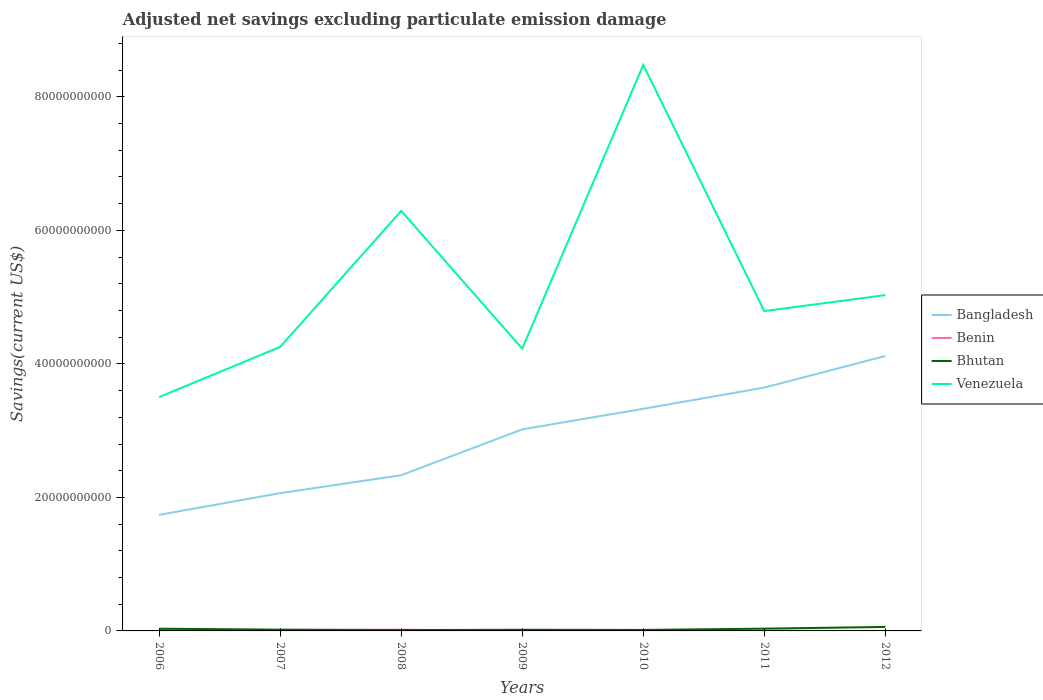How many different coloured lines are there?
Your response must be concise. 4. Is the number of lines equal to the number of legend labels?
Your response must be concise. No. Across all years, what is the maximum adjusted net savings in Venezuela?
Make the answer very short. 3.50e+1. What is the total adjusted net savings in Bhutan in the graph?
Keep it short and to the point. -4.21e+08. What is the difference between the highest and the second highest adjusted net savings in Venezuela?
Your answer should be very brief. 4.98e+1. What is the difference between the highest and the lowest adjusted net savings in Benin?
Your answer should be very brief. 3. Is the adjusted net savings in Bangladesh strictly greater than the adjusted net savings in Venezuela over the years?
Give a very brief answer. Yes. How many lines are there?
Your response must be concise. 4. How are the legend labels stacked?
Provide a succinct answer. Vertical. What is the title of the graph?
Offer a terse response. Adjusted net savings excluding particulate emission damage. Does "Moldova" appear as one of the legend labels in the graph?
Make the answer very short. No. What is the label or title of the X-axis?
Give a very brief answer. Years. What is the label or title of the Y-axis?
Provide a succinct answer. Savings(current US$). What is the Savings(current US$) in Bangladesh in 2006?
Offer a very short reply. 1.74e+1. What is the Savings(current US$) of Benin in 2006?
Offer a terse response. 1.24e+08. What is the Savings(current US$) in Bhutan in 2006?
Your response must be concise. 3.33e+08. What is the Savings(current US$) in Venezuela in 2006?
Your answer should be very brief. 3.50e+1. What is the Savings(current US$) in Bangladesh in 2007?
Your answer should be compact. 2.06e+1. What is the Savings(current US$) in Benin in 2007?
Your response must be concise. 1.34e+08. What is the Savings(current US$) in Bhutan in 2007?
Provide a short and direct response. 1.93e+08. What is the Savings(current US$) in Venezuela in 2007?
Keep it short and to the point. 4.25e+1. What is the Savings(current US$) in Bangladesh in 2008?
Give a very brief answer. 2.33e+1. What is the Savings(current US$) of Benin in 2008?
Offer a very short reply. 1.83e+08. What is the Savings(current US$) in Bhutan in 2008?
Keep it short and to the point. 1.29e+08. What is the Savings(current US$) in Venezuela in 2008?
Offer a very short reply. 6.29e+1. What is the Savings(current US$) of Bangladesh in 2009?
Your answer should be compact. 3.02e+1. What is the Savings(current US$) of Benin in 2009?
Keep it short and to the point. 1.20e+07. What is the Savings(current US$) in Bhutan in 2009?
Your answer should be compact. 1.76e+08. What is the Savings(current US$) in Venezuela in 2009?
Your answer should be very brief. 4.23e+1. What is the Savings(current US$) of Bangladesh in 2010?
Your response must be concise. 3.33e+1. What is the Savings(current US$) of Bhutan in 2010?
Keep it short and to the point. 1.50e+08. What is the Savings(current US$) in Venezuela in 2010?
Offer a terse response. 8.48e+1. What is the Savings(current US$) of Bangladesh in 2011?
Your response must be concise. 3.65e+1. What is the Savings(current US$) of Benin in 2011?
Give a very brief answer. 2.70e+07. What is the Savings(current US$) of Bhutan in 2011?
Your answer should be very brief. 3.40e+08. What is the Savings(current US$) of Venezuela in 2011?
Give a very brief answer. 4.79e+1. What is the Savings(current US$) in Bangladesh in 2012?
Provide a succinct answer. 4.12e+1. What is the Savings(current US$) in Bhutan in 2012?
Keep it short and to the point. 5.96e+08. What is the Savings(current US$) of Venezuela in 2012?
Your answer should be very brief. 5.03e+1. Across all years, what is the maximum Savings(current US$) in Bangladesh?
Ensure brevity in your answer.  4.12e+1. Across all years, what is the maximum Savings(current US$) in Benin?
Your answer should be very brief. 1.83e+08. Across all years, what is the maximum Savings(current US$) in Bhutan?
Your answer should be compact. 5.96e+08. Across all years, what is the maximum Savings(current US$) of Venezuela?
Offer a terse response. 8.48e+1. Across all years, what is the minimum Savings(current US$) of Bangladesh?
Offer a terse response. 1.74e+1. Across all years, what is the minimum Savings(current US$) in Benin?
Offer a terse response. 0. Across all years, what is the minimum Savings(current US$) in Bhutan?
Your answer should be very brief. 1.29e+08. Across all years, what is the minimum Savings(current US$) of Venezuela?
Your answer should be compact. 3.50e+1. What is the total Savings(current US$) of Bangladesh in the graph?
Your answer should be very brief. 2.02e+11. What is the total Savings(current US$) of Benin in the graph?
Ensure brevity in your answer.  4.80e+08. What is the total Savings(current US$) of Bhutan in the graph?
Provide a succinct answer. 1.92e+09. What is the total Savings(current US$) in Venezuela in the graph?
Give a very brief answer. 3.66e+11. What is the difference between the Savings(current US$) of Bangladesh in 2006 and that in 2007?
Provide a short and direct response. -3.25e+09. What is the difference between the Savings(current US$) in Benin in 2006 and that in 2007?
Provide a short and direct response. -1.04e+07. What is the difference between the Savings(current US$) of Bhutan in 2006 and that in 2007?
Make the answer very short. 1.40e+08. What is the difference between the Savings(current US$) in Venezuela in 2006 and that in 2007?
Your answer should be compact. -7.51e+09. What is the difference between the Savings(current US$) of Bangladesh in 2006 and that in 2008?
Ensure brevity in your answer.  -5.94e+09. What is the difference between the Savings(current US$) in Benin in 2006 and that in 2008?
Provide a short and direct response. -5.92e+07. What is the difference between the Savings(current US$) in Bhutan in 2006 and that in 2008?
Ensure brevity in your answer.  2.04e+08. What is the difference between the Savings(current US$) of Venezuela in 2006 and that in 2008?
Offer a very short reply. -2.79e+1. What is the difference between the Savings(current US$) in Bangladesh in 2006 and that in 2009?
Your answer should be compact. -1.28e+1. What is the difference between the Savings(current US$) in Benin in 2006 and that in 2009?
Provide a short and direct response. 1.12e+08. What is the difference between the Savings(current US$) in Bhutan in 2006 and that in 2009?
Make the answer very short. 1.57e+08. What is the difference between the Savings(current US$) in Venezuela in 2006 and that in 2009?
Offer a very short reply. -7.25e+09. What is the difference between the Savings(current US$) in Bangladesh in 2006 and that in 2010?
Your response must be concise. -1.59e+1. What is the difference between the Savings(current US$) in Bhutan in 2006 and that in 2010?
Ensure brevity in your answer.  1.83e+08. What is the difference between the Savings(current US$) in Venezuela in 2006 and that in 2010?
Your answer should be very brief. -4.98e+1. What is the difference between the Savings(current US$) of Bangladesh in 2006 and that in 2011?
Ensure brevity in your answer.  -1.91e+1. What is the difference between the Savings(current US$) in Benin in 2006 and that in 2011?
Make the answer very short. 9.66e+07. What is the difference between the Savings(current US$) of Bhutan in 2006 and that in 2011?
Your answer should be compact. -6.70e+06. What is the difference between the Savings(current US$) in Venezuela in 2006 and that in 2011?
Provide a succinct answer. -1.29e+1. What is the difference between the Savings(current US$) of Bangladesh in 2006 and that in 2012?
Your answer should be very brief. -2.38e+1. What is the difference between the Savings(current US$) of Bhutan in 2006 and that in 2012?
Your answer should be compact. -2.63e+08. What is the difference between the Savings(current US$) of Venezuela in 2006 and that in 2012?
Provide a succinct answer. -1.53e+1. What is the difference between the Savings(current US$) of Bangladesh in 2007 and that in 2008?
Provide a succinct answer. -2.69e+09. What is the difference between the Savings(current US$) in Benin in 2007 and that in 2008?
Offer a terse response. -4.88e+07. What is the difference between the Savings(current US$) of Bhutan in 2007 and that in 2008?
Make the answer very short. 6.32e+07. What is the difference between the Savings(current US$) of Venezuela in 2007 and that in 2008?
Ensure brevity in your answer.  -2.04e+1. What is the difference between the Savings(current US$) of Bangladesh in 2007 and that in 2009?
Your answer should be very brief. -9.55e+09. What is the difference between the Savings(current US$) in Benin in 2007 and that in 2009?
Offer a very short reply. 1.22e+08. What is the difference between the Savings(current US$) in Bhutan in 2007 and that in 2009?
Your answer should be compact. 1.67e+07. What is the difference between the Savings(current US$) of Venezuela in 2007 and that in 2009?
Give a very brief answer. 2.69e+08. What is the difference between the Savings(current US$) of Bangladesh in 2007 and that in 2010?
Provide a succinct answer. -1.26e+1. What is the difference between the Savings(current US$) of Bhutan in 2007 and that in 2010?
Provide a succinct answer. 4.23e+07. What is the difference between the Savings(current US$) of Venezuela in 2007 and that in 2010?
Offer a terse response. -4.22e+1. What is the difference between the Savings(current US$) in Bangladesh in 2007 and that in 2011?
Your response must be concise. -1.58e+1. What is the difference between the Savings(current US$) of Benin in 2007 and that in 2011?
Keep it short and to the point. 1.07e+08. What is the difference between the Savings(current US$) in Bhutan in 2007 and that in 2011?
Your response must be concise. -1.47e+08. What is the difference between the Savings(current US$) in Venezuela in 2007 and that in 2011?
Your response must be concise. -5.37e+09. What is the difference between the Savings(current US$) of Bangladesh in 2007 and that in 2012?
Offer a very short reply. -2.05e+1. What is the difference between the Savings(current US$) in Bhutan in 2007 and that in 2012?
Your response must be concise. -4.04e+08. What is the difference between the Savings(current US$) of Venezuela in 2007 and that in 2012?
Ensure brevity in your answer.  -7.76e+09. What is the difference between the Savings(current US$) in Bangladesh in 2008 and that in 2009?
Your answer should be very brief. -6.87e+09. What is the difference between the Savings(current US$) in Benin in 2008 and that in 2009?
Give a very brief answer. 1.71e+08. What is the difference between the Savings(current US$) in Bhutan in 2008 and that in 2009?
Offer a very short reply. -4.65e+07. What is the difference between the Savings(current US$) of Venezuela in 2008 and that in 2009?
Give a very brief answer. 2.06e+1. What is the difference between the Savings(current US$) in Bangladesh in 2008 and that in 2010?
Keep it short and to the point. -9.95e+09. What is the difference between the Savings(current US$) in Bhutan in 2008 and that in 2010?
Your answer should be compact. -2.10e+07. What is the difference between the Savings(current US$) of Venezuela in 2008 and that in 2010?
Offer a terse response. -2.19e+1. What is the difference between the Savings(current US$) of Bangladesh in 2008 and that in 2011?
Give a very brief answer. -1.31e+1. What is the difference between the Savings(current US$) of Benin in 2008 and that in 2011?
Ensure brevity in your answer.  1.56e+08. What is the difference between the Savings(current US$) of Bhutan in 2008 and that in 2011?
Your response must be concise. -2.10e+08. What is the difference between the Savings(current US$) in Venezuela in 2008 and that in 2011?
Your response must be concise. 1.50e+1. What is the difference between the Savings(current US$) in Bangladesh in 2008 and that in 2012?
Provide a short and direct response. -1.79e+1. What is the difference between the Savings(current US$) of Bhutan in 2008 and that in 2012?
Your answer should be compact. -4.67e+08. What is the difference between the Savings(current US$) of Venezuela in 2008 and that in 2012?
Offer a very short reply. 1.26e+1. What is the difference between the Savings(current US$) of Bangladesh in 2009 and that in 2010?
Provide a short and direct response. -3.08e+09. What is the difference between the Savings(current US$) in Bhutan in 2009 and that in 2010?
Offer a terse response. 2.55e+07. What is the difference between the Savings(current US$) in Venezuela in 2009 and that in 2010?
Your response must be concise. -4.25e+1. What is the difference between the Savings(current US$) in Bangladesh in 2009 and that in 2011?
Offer a very short reply. -6.26e+09. What is the difference between the Savings(current US$) of Benin in 2009 and that in 2011?
Your response must be concise. -1.50e+07. What is the difference between the Savings(current US$) in Bhutan in 2009 and that in 2011?
Keep it short and to the point. -1.64e+08. What is the difference between the Savings(current US$) of Venezuela in 2009 and that in 2011?
Offer a terse response. -5.63e+09. What is the difference between the Savings(current US$) in Bangladesh in 2009 and that in 2012?
Your answer should be very brief. -1.10e+1. What is the difference between the Savings(current US$) of Bhutan in 2009 and that in 2012?
Your answer should be compact. -4.21e+08. What is the difference between the Savings(current US$) of Venezuela in 2009 and that in 2012?
Your response must be concise. -8.03e+09. What is the difference between the Savings(current US$) of Bangladesh in 2010 and that in 2011?
Ensure brevity in your answer.  -3.17e+09. What is the difference between the Savings(current US$) in Bhutan in 2010 and that in 2011?
Your response must be concise. -1.89e+08. What is the difference between the Savings(current US$) in Venezuela in 2010 and that in 2011?
Make the answer very short. 3.69e+1. What is the difference between the Savings(current US$) in Bangladesh in 2010 and that in 2012?
Ensure brevity in your answer.  -7.90e+09. What is the difference between the Savings(current US$) in Bhutan in 2010 and that in 2012?
Provide a succinct answer. -4.46e+08. What is the difference between the Savings(current US$) of Venezuela in 2010 and that in 2012?
Provide a short and direct response. 3.45e+1. What is the difference between the Savings(current US$) in Bangladesh in 2011 and that in 2012?
Provide a succinct answer. -4.73e+09. What is the difference between the Savings(current US$) in Bhutan in 2011 and that in 2012?
Make the answer very short. -2.57e+08. What is the difference between the Savings(current US$) of Venezuela in 2011 and that in 2012?
Your answer should be very brief. -2.39e+09. What is the difference between the Savings(current US$) in Bangladesh in 2006 and the Savings(current US$) in Benin in 2007?
Ensure brevity in your answer.  1.73e+1. What is the difference between the Savings(current US$) in Bangladesh in 2006 and the Savings(current US$) in Bhutan in 2007?
Your answer should be compact. 1.72e+1. What is the difference between the Savings(current US$) of Bangladesh in 2006 and the Savings(current US$) of Venezuela in 2007?
Ensure brevity in your answer.  -2.52e+1. What is the difference between the Savings(current US$) in Benin in 2006 and the Savings(current US$) in Bhutan in 2007?
Offer a very short reply. -6.90e+07. What is the difference between the Savings(current US$) in Benin in 2006 and the Savings(current US$) in Venezuela in 2007?
Ensure brevity in your answer.  -4.24e+1. What is the difference between the Savings(current US$) of Bhutan in 2006 and the Savings(current US$) of Venezuela in 2007?
Your response must be concise. -4.22e+1. What is the difference between the Savings(current US$) in Bangladesh in 2006 and the Savings(current US$) in Benin in 2008?
Ensure brevity in your answer.  1.72e+1. What is the difference between the Savings(current US$) of Bangladesh in 2006 and the Savings(current US$) of Bhutan in 2008?
Keep it short and to the point. 1.73e+1. What is the difference between the Savings(current US$) in Bangladesh in 2006 and the Savings(current US$) in Venezuela in 2008?
Your answer should be compact. -4.55e+1. What is the difference between the Savings(current US$) in Benin in 2006 and the Savings(current US$) in Bhutan in 2008?
Offer a very short reply. -5.82e+06. What is the difference between the Savings(current US$) in Benin in 2006 and the Savings(current US$) in Venezuela in 2008?
Your answer should be compact. -6.28e+1. What is the difference between the Savings(current US$) in Bhutan in 2006 and the Savings(current US$) in Venezuela in 2008?
Offer a very short reply. -6.26e+1. What is the difference between the Savings(current US$) in Bangladesh in 2006 and the Savings(current US$) in Benin in 2009?
Ensure brevity in your answer.  1.74e+1. What is the difference between the Savings(current US$) in Bangladesh in 2006 and the Savings(current US$) in Bhutan in 2009?
Your answer should be compact. 1.72e+1. What is the difference between the Savings(current US$) of Bangladesh in 2006 and the Savings(current US$) of Venezuela in 2009?
Your answer should be very brief. -2.49e+1. What is the difference between the Savings(current US$) in Benin in 2006 and the Savings(current US$) in Bhutan in 2009?
Provide a succinct answer. -5.23e+07. What is the difference between the Savings(current US$) in Benin in 2006 and the Savings(current US$) in Venezuela in 2009?
Give a very brief answer. -4.22e+1. What is the difference between the Savings(current US$) in Bhutan in 2006 and the Savings(current US$) in Venezuela in 2009?
Provide a short and direct response. -4.19e+1. What is the difference between the Savings(current US$) of Bangladesh in 2006 and the Savings(current US$) of Bhutan in 2010?
Ensure brevity in your answer.  1.72e+1. What is the difference between the Savings(current US$) of Bangladesh in 2006 and the Savings(current US$) of Venezuela in 2010?
Your response must be concise. -6.74e+1. What is the difference between the Savings(current US$) in Benin in 2006 and the Savings(current US$) in Bhutan in 2010?
Your response must be concise. -2.68e+07. What is the difference between the Savings(current US$) in Benin in 2006 and the Savings(current US$) in Venezuela in 2010?
Your answer should be very brief. -8.47e+1. What is the difference between the Savings(current US$) of Bhutan in 2006 and the Savings(current US$) of Venezuela in 2010?
Offer a very short reply. -8.45e+1. What is the difference between the Savings(current US$) in Bangladesh in 2006 and the Savings(current US$) in Benin in 2011?
Provide a short and direct response. 1.74e+1. What is the difference between the Savings(current US$) of Bangladesh in 2006 and the Savings(current US$) of Bhutan in 2011?
Offer a terse response. 1.70e+1. What is the difference between the Savings(current US$) of Bangladesh in 2006 and the Savings(current US$) of Venezuela in 2011?
Offer a very short reply. -3.05e+1. What is the difference between the Savings(current US$) of Benin in 2006 and the Savings(current US$) of Bhutan in 2011?
Offer a terse response. -2.16e+08. What is the difference between the Savings(current US$) of Benin in 2006 and the Savings(current US$) of Venezuela in 2011?
Your response must be concise. -4.78e+1. What is the difference between the Savings(current US$) in Bhutan in 2006 and the Savings(current US$) in Venezuela in 2011?
Make the answer very short. -4.76e+1. What is the difference between the Savings(current US$) of Bangladesh in 2006 and the Savings(current US$) of Bhutan in 2012?
Ensure brevity in your answer.  1.68e+1. What is the difference between the Savings(current US$) of Bangladesh in 2006 and the Savings(current US$) of Venezuela in 2012?
Your answer should be compact. -3.29e+1. What is the difference between the Savings(current US$) of Benin in 2006 and the Savings(current US$) of Bhutan in 2012?
Keep it short and to the point. -4.73e+08. What is the difference between the Savings(current US$) of Benin in 2006 and the Savings(current US$) of Venezuela in 2012?
Give a very brief answer. -5.02e+1. What is the difference between the Savings(current US$) in Bhutan in 2006 and the Savings(current US$) in Venezuela in 2012?
Keep it short and to the point. -5.00e+1. What is the difference between the Savings(current US$) in Bangladesh in 2007 and the Savings(current US$) in Benin in 2008?
Provide a short and direct response. 2.05e+1. What is the difference between the Savings(current US$) in Bangladesh in 2007 and the Savings(current US$) in Bhutan in 2008?
Provide a succinct answer. 2.05e+1. What is the difference between the Savings(current US$) of Bangladesh in 2007 and the Savings(current US$) of Venezuela in 2008?
Ensure brevity in your answer.  -4.23e+1. What is the difference between the Savings(current US$) of Benin in 2007 and the Savings(current US$) of Bhutan in 2008?
Your response must be concise. 4.55e+06. What is the difference between the Savings(current US$) of Benin in 2007 and the Savings(current US$) of Venezuela in 2008?
Keep it short and to the point. -6.28e+1. What is the difference between the Savings(current US$) of Bhutan in 2007 and the Savings(current US$) of Venezuela in 2008?
Offer a terse response. -6.27e+1. What is the difference between the Savings(current US$) in Bangladesh in 2007 and the Savings(current US$) in Benin in 2009?
Offer a terse response. 2.06e+1. What is the difference between the Savings(current US$) in Bangladesh in 2007 and the Savings(current US$) in Bhutan in 2009?
Your answer should be compact. 2.05e+1. What is the difference between the Savings(current US$) in Bangladesh in 2007 and the Savings(current US$) in Venezuela in 2009?
Your response must be concise. -2.16e+1. What is the difference between the Savings(current US$) of Benin in 2007 and the Savings(current US$) of Bhutan in 2009?
Offer a terse response. -4.19e+07. What is the difference between the Savings(current US$) in Benin in 2007 and the Savings(current US$) in Venezuela in 2009?
Ensure brevity in your answer.  -4.21e+1. What is the difference between the Savings(current US$) of Bhutan in 2007 and the Savings(current US$) of Venezuela in 2009?
Keep it short and to the point. -4.21e+1. What is the difference between the Savings(current US$) in Bangladesh in 2007 and the Savings(current US$) in Bhutan in 2010?
Provide a short and direct response. 2.05e+1. What is the difference between the Savings(current US$) of Bangladesh in 2007 and the Savings(current US$) of Venezuela in 2010?
Ensure brevity in your answer.  -6.42e+1. What is the difference between the Savings(current US$) in Benin in 2007 and the Savings(current US$) in Bhutan in 2010?
Your response must be concise. -1.64e+07. What is the difference between the Savings(current US$) of Benin in 2007 and the Savings(current US$) of Venezuela in 2010?
Provide a short and direct response. -8.47e+1. What is the difference between the Savings(current US$) of Bhutan in 2007 and the Savings(current US$) of Venezuela in 2010?
Provide a succinct answer. -8.46e+1. What is the difference between the Savings(current US$) of Bangladesh in 2007 and the Savings(current US$) of Benin in 2011?
Give a very brief answer. 2.06e+1. What is the difference between the Savings(current US$) of Bangladesh in 2007 and the Savings(current US$) of Bhutan in 2011?
Your answer should be compact. 2.03e+1. What is the difference between the Savings(current US$) in Bangladesh in 2007 and the Savings(current US$) in Venezuela in 2011?
Make the answer very short. -2.73e+1. What is the difference between the Savings(current US$) of Benin in 2007 and the Savings(current US$) of Bhutan in 2011?
Your answer should be very brief. -2.06e+08. What is the difference between the Savings(current US$) of Benin in 2007 and the Savings(current US$) of Venezuela in 2011?
Provide a short and direct response. -4.78e+1. What is the difference between the Savings(current US$) of Bhutan in 2007 and the Savings(current US$) of Venezuela in 2011?
Provide a short and direct response. -4.77e+1. What is the difference between the Savings(current US$) in Bangladesh in 2007 and the Savings(current US$) in Bhutan in 2012?
Provide a succinct answer. 2.00e+1. What is the difference between the Savings(current US$) of Bangladesh in 2007 and the Savings(current US$) of Venezuela in 2012?
Give a very brief answer. -2.97e+1. What is the difference between the Savings(current US$) of Benin in 2007 and the Savings(current US$) of Bhutan in 2012?
Keep it short and to the point. -4.62e+08. What is the difference between the Savings(current US$) of Benin in 2007 and the Savings(current US$) of Venezuela in 2012?
Keep it short and to the point. -5.02e+1. What is the difference between the Savings(current US$) in Bhutan in 2007 and the Savings(current US$) in Venezuela in 2012?
Provide a succinct answer. -5.01e+1. What is the difference between the Savings(current US$) of Bangladesh in 2008 and the Savings(current US$) of Benin in 2009?
Provide a short and direct response. 2.33e+1. What is the difference between the Savings(current US$) in Bangladesh in 2008 and the Savings(current US$) in Bhutan in 2009?
Keep it short and to the point. 2.31e+1. What is the difference between the Savings(current US$) of Bangladesh in 2008 and the Savings(current US$) of Venezuela in 2009?
Offer a terse response. -1.90e+1. What is the difference between the Savings(current US$) of Benin in 2008 and the Savings(current US$) of Bhutan in 2009?
Keep it short and to the point. 6.90e+06. What is the difference between the Savings(current US$) of Benin in 2008 and the Savings(current US$) of Venezuela in 2009?
Offer a terse response. -4.21e+1. What is the difference between the Savings(current US$) of Bhutan in 2008 and the Savings(current US$) of Venezuela in 2009?
Provide a succinct answer. -4.21e+1. What is the difference between the Savings(current US$) of Bangladesh in 2008 and the Savings(current US$) of Bhutan in 2010?
Provide a short and direct response. 2.32e+1. What is the difference between the Savings(current US$) of Bangladesh in 2008 and the Savings(current US$) of Venezuela in 2010?
Your answer should be compact. -6.15e+1. What is the difference between the Savings(current US$) of Benin in 2008 and the Savings(current US$) of Bhutan in 2010?
Provide a succinct answer. 3.24e+07. What is the difference between the Savings(current US$) in Benin in 2008 and the Savings(current US$) in Venezuela in 2010?
Make the answer very short. -8.46e+1. What is the difference between the Savings(current US$) of Bhutan in 2008 and the Savings(current US$) of Venezuela in 2010?
Ensure brevity in your answer.  -8.47e+1. What is the difference between the Savings(current US$) of Bangladesh in 2008 and the Savings(current US$) of Benin in 2011?
Offer a very short reply. 2.33e+1. What is the difference between the Savings(current US$) of Bangladesh in 2008 and the Savings(current US$) of Bhutan in 2011?
Make the answer very short. 2.30e+1. What is the difference between the Savings(current US$) in Bangladesh in 2008 and the Savings(current US$) in Venezuela in 2011?
Offer a terse response. -2.46e+1. What is the difference between the Savings(current US$) of Benin in 2008 and the Savings(current US$) of Bhutan in 2011?
Give a very brief answer. -1.57e+08. What is the difference between the Savings(current US$) of Benin in 2008 and the Savings(current US$) of Venezuela in 2011?
Keep it short and to the point. -4.77e+1. What is the difference between the Savings(current US$) of Bhutan in 2008 and the Savings(current US$) of Venezuela in 2011?
Give a very brief answer. -4.78e+1. What is the difference between the Savings(current US$) in Bangladesh in 2008 and the Savings(current US$) in Bhutan in 2012?
Make the answer very short. 2.27e+1. What is the difference between the Savings(current US$) of Bangladesh in 2008 and the Savings(current US$) of Venezuela in 2012?
Your response must be concise. -2.70e+1. What is the difference between the Savings(current US$) in Benin in 2008 and the Savings(current US$) in Bhutan in 2012?
Give a very brief answer. -4.14e+08. What is the difference between the Savings(current US$) in Benin in 2008 and the Savings(current US$) in Venezuela in 2012?
Your answer should be very brief. -5.01e+1. What is the difference between the Savings(current US$) in Bhutan in 2008 and the Savings(current US$) in Venezuela in 2012?
Offer a very short reply. -5.02e+1. What is the difference between the Savings(current US$) of Bangladesh in 2009 and the Savings(current US$) of Bhutan in 2010?
Offer a terse response. 3.00e+1. What is the difference between the Savings(current US$) in Bangladesh in 2009 and the Savings(current US$) in Venezuela in 2010?
Ensure brevity in your answer.  -5.46e+1. What is the difference between the Savings(current US$) in Benin in 2009 and the Savings(current US$) in Bhutan in 2010?
Ensure brevity in your answer.  -1.38e+08. What is the difference between the Savings(current US$) in Benin in 2009 and the Savings(current US$) in Venezuela in 2010?
Provide a succinct answer. -8.48e+1. What is the difference between the Savings(current US$) of Bhutan in 2009 and the Savings(current US$) of Venezuela in 2010?
Make the answer very short. -8.46e+1. What is the difference between the Savings(current US$) in Bangladesh in 2009 and the Savings(current US$) in Benin in 2011?
Keep it short and to the point. 3.02e+1. What is the difference between the Savings(current US$) in Bangladesh in 2009 and the Savings(current US$) in Bhutan in 2011?
Make the answer very short. 2.99e+1. What is the difference between the Savings(current US$) of Bangladesh in 2009 and the Savings(current US$) of Venezuela in 2011?
Provide a succinct answer. -1.77e+1. What is the difference between the Savings(current US$) in Benin in 2009 and the Savings(current US$) in Bhutan in 2011?
Provide a short and direct response. -3.28e+08. What is the difference between the Savings(current US$) of Benin in 2009 and the Savings(current US$) of Venezuela in 2011?
Your answer should be very brief. -4.79e+1. What is the difference between the Savings(current US$) of Bhutan in 2009 and the Savings(current US$) of Venezuela in 2011?
Offer a terse response. -4.77e+1. What is the difference between the Savings(current US$) in Bangladesh in 2009 and the Savings(current US$) in Bhutan in 2012?
Keep it short and to the point. 2.96e+1. What is the difference between the Savings(current US$) in Bangladesh in 2009 and the Savings(current US$) in Venezuela in 2012?
Offer a very short reply. -2.01e+1. What is the difference between the Savings(current US$) of Benin in 2009 and the Savings(current US$) of Bhutan in 2012?
Give a very brief answer. -5.84e+08. What is the difference between the Savings(current US$) in Benin in 2009 and the Savings(current US$) in Venezuela in 2012?
Provide a succinct answer. -5.03e+1. What is the difference between the Savings(current US$) of Bhutan in 2009 and the Savings(current US$) of Venezuela in 2012?
Offer a terse response. -5.01e+1. What is the difference between the Savings(current US$) of Bangladesh in 2010 and the Savings(current US$) of Benin in 2011?
Your response must be concise. 3.33e+1. What is the difference between the Savings(current US$) of Bangladesh in 2010 and the Savings(current US$) of Bhutan in 2011?
Offer a terse response. 3.29e+1. What is the difference between the Savings(current US$) in Bangladesh in 2010 and the Savings(current US$) in Venezuela in 2011?
Offer a terse response. -1.46e+1. What is the difference between the Savings(current US$) of Bhutan in 2010 and the Savings(current US$) of Venezuela in 2011?
Provide a short and direct response. -4.78e+1. What is the difference between the Savings(current US$) of Bangladesh in 2010 and the Savings(current US$) of Bhutan in 2012?
Offer a terse response. 3.27e+1. What is the difference between the Savings(current US$) in Bangladesh in 2010 and the Savings(current US$) in Venezuela in 2012?
Ensure brevity in your answer.  -1.70e+1. What is the difference between the Savings(current US$) of Bhutan in 2010 and the Savings(current US$) of Venezuela in 2012?
Your answer should be very brief. -5.02e+1. What is the difference between the Savings(current US$) in Bangladesh in 2011 and the Savings(current US$) in Bhutan in 2012?
Make the answer very short. 3.59e+1. What is the difference between the Savings(current US$) of Bangladesh in 2011 and the Savings(current US$) of Venezuela in 2012?
Your answer should be very brief. -1.39e+1. What is the difference between the Savings(current US$) in Benin in 2011 and the Savings(current US$) in Bhutan in 2012?
Make the answer very short. -5.69e+08. What is the difference between the Savings(current US$) in Benin in 2011 and the Savings(current US$) in Venezuela in 2012?
Your response must be concise. -5.03e+1. What is the difference between the Savings(current US$) of Bhutan in 2011 and the Savings(current US$) of Venezuela in 2012?
Offer a very short reply. -5.00e+1. What is the average Savings(current US$) of Bangladesh per year?
Make the answer very short. 2.89e+1. What is the average Savings(current US$) in Benin per year?
Your answer should be compact. 6.85e+07. What is the average Savings(current US$) in Bhutan per year?
Keep it short and to the point. 2.74e+08. What is the average Savings(current US$) of Venezuela per year?
Keep it short and to the point. 5.23e+1. In the year 2006, what is the difference between the Savings(current US$) in Bangladesh and Savings(current US$) in Benin?
Your response must be concise. 1.73e+1. In the year 2006, what is the difference between the Savings(current US$) of Bangladesh and Savings(current US$) of Bhutan?
Ensure brevity in your answer.  1.71e+1. In the year 2006, what is the difference between the Savings(current US$) of Bangladesh and Savings(current US$) of Venezuela?
Provide a succinct answer. -1.76e+1. In the year 2006, what is the difference between the Savings(current US$) in Benin and Savings(current US$) in Bhutan?
Give a very brief answer. -2.09e+08. In the year 2006, what is the difference between the Savings(current US$) in Benin and Savings(current US$) in Venezuela?
Your answer should be compact. -3.49e+1. In the year 2006, what is the difference between the Savings(current US$) of Bhutan and Savings(current US$) of Venezuela?
Your answer should be very brief. -3.47e+1. In the year 2007, what is the difference between the Savings(current US$) in Bangladesh and Savings(current US$) in Benin?
Make the answer very short. 2.05e+1. In the year 2007, what is the difference between the Savings(current US$) in Bangladesh and Savings(current US$) in Bhutan?
Keep it short and to the point. 2.04e+1. In the year 2007, what is the difference between the Savings(current US$) in Bangladesh and Savings(current US$) in Venezuela?
Your answer should be very brief. -2.19e+1. In the year 2007, what is the difference between the Savings(current US$) of Benin and Savings(current US$) of Bhutan?
Offer a terse response. -5.87e+07. In the year 2007, what is the difference between the Savings(current US$) in Benin and Savings(current US$) in Venezuela?
Offer a terse response. -4.24e+1. In the year 2007, what is the difference between the Savings(current US$) of Bhutan and Savings(current US$) of Venezuela?
Offer a very short reply. -4.24e+1. In the year 2008, what is the difference between the Savings(current US$) in Bangladesh and Savings(current US$) in Benin?
Offer a very short reply. 2.31e+1. In the year 2008, what is the difference between the Savings(current US$) in Bangladesh and Savings(current US$) in Bhutan?
Your answer should be compact. 2.32e+1. In the year 2008, what is the difference between the Savings(current US$) of Bangladesh and Savings(current US$) of Venezuela?
Offer a terse response. -3.96e+1. In the year 2008, what is the difference between the Savings(current US$) in Benin and Savings(current US$) in Bhutan?
Make the answer very short. 5.34e+07. In the year 2008, what is the difference between the Savings(current US$) of Benin and Savings(current US$) of Venezuela?
Ensure brevity in your answer.  -6.27e+1. In the year 2008, what is the difference between the Savings(current US$) in Bhutan and Savings(current US$) in Venezuela?
Keep it short and to the point. -6.28e+1. In the year 2009, what is the difference between the Savings(current US$) in Bangladesh and Savings(current US$) in Benin?
Provide a succinct answer. 3.02e+1. In the year 2009, what is the difference between the Savings(current US$) of Bangladesh and Savings(current US$) of Bhutan?
Your answer should be compact. 3.00e+1. In the year 2009, what is the difference between the Savings(current US$) of Bangladesh and Savings(current US$) of Venezuela?
Make the answer very short. -1.21e+1. In the year 2009, what is the difference between the Savings(current US$) in Benin and Savings(current US$) in Bhutan?
Your response must be concise. -1.64e+08. In the year 2009, what is the difference between the Savings(current US$) in Benin and Savings(current US$) in Venezuela?
Your answer should be compact. -4.23e+1. In the year 2009, what is the difference between the Savings(current US$) in Bhutan and Savings(current US$) in Venezuela?
Offer a very short reply. -4.21e+1. In the year 2010, what is the difference between the Savings(current US$) of Bangladesh and Savings(current US$) of Bhutan?
Your response must be concise. 3.31e+1. In the year 2010, what is the difference between the Savings(current US$) in Bangladesh and Savings(current US$) in Venezuela?
Your answer should be compact. -5.15e+1. In the year 2010, what is the difference between the Savings(current US$) in Bhutan and Savings(current US$) in Venezuela?
Your answer should be very brief. -8.46e+1. In the year 2011, what is the difference between the Savings(current US$) of Bangladesh and Savings(current US$) of Benin?
Your response must be concise. 3.64e+1. In the year 2011, what is the difference between the Savings(current US$) of Bangladesh and Savings(current US$) of Bhutan?
Make the answer very short. 3.61e+1. In the year 2011, what is the difference between the Savings(current US$) in Bangladesh and Savings(current US$) in Venezuela?
Ensure brevity in your answer.  -1.15e+1. In the year 2011, what is the difference between the Savings(current US$) of Benin and Savings(current US$) of Bhutan?
Your response must be concise. -3.13e+08. In the year 2011, what is the difference between the Savings(current US$) of Benin and Savings(current US$) of Venezuela?
Give a very brief answer. -4.79e+1. In the year 2011, what is the difference between the Savings(current US$) of Bhutan and Savings(current US$) of Venezuela?
Give a very brief answer. -4.76e+1. In the year 2012, what is the difference between the Savings(current US$) in Bangladesh and Savings(current US$) in Bhutan?
Provide a succinct answer. 4.06e+1. In the year 2012, what is the difference between the Savings(current US$) of Bangladesh and Savings(current US$) of Venezuela?
Your response must be concise. -9.12e+09. In the year 2012, what is the difference between the Savings(current US$) of Bhutan and Savings(current US$) of Venezuela?
Give a very brief answer. -4.97e+1. What is the ratio of the Savings(current US$) in Bangladesh in 2006 to that in 2007?
Keep it short and to the point. 0.84. What is the ratio of the Savings(current US$) in Benin in 2006 to that in 2007?
Offer a very short reply. 0.92. What is the ratio of the Savings(current US$) in Bhutan in 2006 to that in 2007?
Your response must be concise. 1.73. What is the ratio of the Savings(current US$) of Venezuela in 2006 to that in 2007?
Offer a terse response. 0.82. What is the ratio of the Savings(current US$) of Bangladesh in 2006 to that in 2008?
Give a very brief answer. 0.75. What is the ratio of the Savings(current US$) in Benin in 2006 to that in 2008?
Offer a terse response. 0.68. What is the ratio of the Savings(current US$) of Bhutan in 2006 to that in 2008?
Make the answer very short. 2.57. What is the ratio of the Savings(current US$) of Venezuela in 2006 to that in 2008?
Your answer should be compact. 0.56. What is the ratio of the Savings(current US$) of Bangladesh in 2006 to that in 2009?
Your response must be concise. 0.58. What is the ratio of the Savings(current US$) in Benin in 2006 to that in 2009?
Offer a very short reply. 10.26. What is the ratio of the Savings(current US$) of Bhutan in 2006 to that in 2009?
Give a very brief answer. 1.89. What is the ratio of the Savings(current US$) in Venezuela in 2006 to that in 2009?
Provide a short and direct response. 0.83. What is the ratio of the Savings(current US$) of Bangladesh in 2006 to that in 2010?
Your response must be concise. 0.52. What is the ratio of the Savings(current US$) of Bhutan in 2006 to that in 2010?
Offer a terse response. 2.21. What is the ratio of the Savings(current US$) of Venezuela in 2006 to that in 2010?
Provide a succinct answer. 0.41. What is the ratio of the Savings(current US$) of Bangladesh in 2006 to that in 2011?
Provide a short and direct response. 0.48. What is the ratio of the Savings(current US$) in Benin in 2006 to that in 2011?
Keep it short and to the point. 4.58. What is the ratio of the Savings(current US$) in Bhutan in 2006 to that in 2011?
Make the answer very short. 0.98. What is the ratio of the Savings(current US$) of Venezuela in 2006 to that in 2011?
Give a very brief answer. 0.73. What is the ratio of the Savings(current US$) of Bangladesh in 2006 to that in 2012?
Offer a terse response. 0.42. What is the ratio of the Savings(current US$) of Bhutan in 2006 to that in 2012?
Make the answer very short. 0.56. What is the ratio of the Savings(current US$) of Venezuela in 2006 to that in 2012?
Ensure brevity in your answer.  0.7. What is the ratio of the Savings(current US$) in Bangladesh in 2007 to that in 2008?
Your answer should be compact. 0.88. What is the ratio of the Savings(current US$) of Benin in 2007 to that in 2008?
Give a very brief answer. 0.73. What is the ratio of the Savings(current US$) of Bhutan in 2007 to that in 2008?
Keep it short and to the point. 1.49. What is the ratio of the Savings(current US$) of Venezuela in 2007 to that in 2008?
Offer a terse response. 0.68. What is the ratio of the Savings(current US$) of Bangladesh in 2007 to that in 2009?
Offer a terse response. 0.68. What is the ratio of the Savings(current US$) in Benin in 2007 to that in 2009?
Offer a terse response. 11.13. What is the ratio of the Savings(current US$) of Bhutan in 2007 to that in 2009?
Ensure brevity in your answer.  1.1. What is the ratio of the Savings(current US$) of Venezuela in 2007 to that in 2009?
Your answer should be compact. 1.01. What is the ratio of the Savings(current US$) of Bangladesh in 2007 to that in 2010?
Ensure brevity in your answer.  0.62. What is the ratio of the Savings(current US$) of Bhutan in 2007 to that in 2010?
Your answer should be compact. 1.28. What is the ratio of the Savings(current US$) in Venezuela in 2007 to that in 2010?
Give a very brief answer. 0.5. What is the ratio of the Savings(current US$) in Bangladesh in 2007 to that in 2011?
Your answer should be very brief. 0.57. What is the ratio of the Savings(current US$) in Benin in 2007 to that in 2011?
Your answer should be very brief. 4.96. What is the ratio of the Savings(current US$) of Bhutan in 2007 to that in 2011?
Your answer should be very brief. 0.57. What is the ratio of the Savings(current US$) in Venezuela in 2007 to that in 2011?
Provide a short and direct response. 0.89. What is the ratio of the Savings(current US$) of Bangladesh in 2007 to that in 2012?
Give a very brief answer. 0.5. What is the ratio of the Savings(current US$) of Bhutan in 2007 to that in 2012?
Provide a succinct answer. 0.32. What is the ratio of the Savings(current US$) in Venezuela in 2007 to that in 2012?
Your response must be concise. 0.85. What is the ratio of the Savings(current US$) in Bangladesh in 2008 to that in 2009?
Provide a short and direct response. 0.77. What is the ratio of the Savings(current US$) in Benin in 2008 to that in 2009?
Your answer should be very brief. 15.18. What is the ratio of the Savings(current US$) in Bhutan in 2008 to that in 2009?
Provide a succinct answer. 0.74. What is the ratio of the Savings(current US$) in Venezuela in 2008 to that in 2009?
Your answer should be compact. 1.49. What is the ratio of the Savings(current US$) in Bangladesh in 2008 to that in 2010?
Offer a very short reply. 0.7. What is the ratio of the Savings(current US$) in Bhutan in 2008 to that in 2010?
Keep it short and to the point. 0.86. What is the ratio of the Savings(current US$) of Venezuela in 2008 to that in 2010?
Provide a succinct answer. 0.74. What is the ratio of the Savings(current US$) in Bangladesh in 2008 to that in 2011?
Provide a short and direct response. 0.64. What is the ratio of the Savings(current US$) of Benin in 2008 to that in 2011?
Your response must be concise. 6.77. What is the ratio of the Savings(current US$) in Bhutan in 2008 to that in 2011?
Offer a very short reply. 0.38. What is the ratio of the Savings(current US$) of Venezuela in 2008 to that in 2011?
Provide a short and direct response. 1.31. What is the ratio of the Savings(current US$) of Bangladesh in 2008 to that in 2012?
Make the answer very short. 0.57. What is the ratio of the Savings(current US$) of Bhutan in 2008 to that in 2012?
Keep it short and to the point. 0.22. What is the ratio of the Savings(current US$) of Venezuela in 2008 to that in 2012?
Make the answer very short. 1.25. What is the ratio of the Savings(current US$) in Bangladesh in 2009 to that in 2010?
Offer a terse response. 0.91. What is the ratio of the Savings(current US$) in Bhutan in 2009 to that in 2010?
Your answer should be very brief. 1.17. What is the ratio of the Savings(current US$) of Venezuela in 2009 to that in 2010?
Your answer should be compact. 0.5. What is the ratio of the Savings(current US$) of Bangladesh in 2009 to that in 2011?
Offer a very short reply. 0.83. What is the ratio of the Savings(current US$) in Benin in 2009 to that in 2011?
Keep it short and to the point. 0.45. What is the ratio of the Savings(current US$) of Bhutan in 2009 to that in 2011?
Offer a very short reply. 0.52. What is the ratio of the Savings(current US$) in Venezuela in 2009 to that in 2011?
Provide a short and direct response. 0.88. What is the ratio of the Savings(current US$) of Bangladesh in 2009 to that in 2012?
Your answer should be compact. 0.73. What is the ratio of the Savings(current US$) of Bhutan in 2009 to that in 2012?
Give a very brief answer. 0.29. What is the ratio of the Savings(current US$) of Venezuela in 2009 to that in 2012?
Make the answer very short. 0.84. What is the ratio of the Savings(current US$) in Bangladesh in 2010 to that in 2011?
Offer a terse response. 0.91. What is the ratio of the Savings(current US$) of Bhutan in 2010 to that in 2011?
Ensure brevity in your answer.  0.44. What is the ratio of the Savings(current US$) of Venezuela in 2010 to that in 2011?
Ensure brevity in your answer.  1.77. What is the ratio of the Savings(current US$) of Bangladesh in 2010 to that in 2012?
Your answer should be compact. 0.81. What is the ratio of the Savings(current US$) in Bhutan in 2010 to that in 2012?
Provide a short and direct response. 0.25. What is the ratio of the Savings(current US$) in Venezuela in 2010 to that in 2012?
Your answer should be very brief. 1.69. What is the ratio of the Savings(current US$) of Bangladesh in 2011 to that in 2012?
Provide a short and direct response. 0.89. What is the ratio of the Savings(current US$) in Bhutan in 2011 to that in 2012?
Your answer should be very brief. 0.57. What is the difference between the highest and the second highest Savings(current US$) of Bangladesh?
Make the answer very short. 4.73e+09. What is the difference between the highest and the second highest Savings(current US$) in Benin?
Offer a very short reply. 4.88e+07. What is the difference between the highest and the second highest Savings(current US$) in Bhutan?
Offer a terse response. 2.57e+08. What is the difference between the highest and the second highest Savings(current US$) in Venezuela?
Make the answer very short. 2.19e+1. What is the difference between the highest and the lowest Savings(current US$) of Bangladesh?
Your answer should be compact. 2.38e+1. What is the difference between the highest and the lowest Savings(current US$) of Benin?
Keep it short and to the point. 1.83e+08. What is the difference between the highest and the lowest Savings(current US$) of Bhutan?
Offer a very short reply. 4.67e+08. What is the difference between the highest and the lowest Savings(current US$) in Venezuela?
Give a very brief answer. 4.98e+1. 